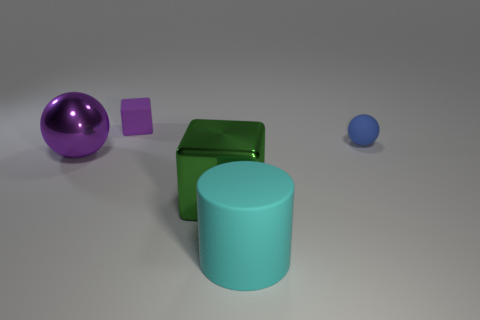Add 5 big yellow metal objects. How many objects exist? 10 Subtract all cylinders. How many objects are left? 4 Add 5 green shiny blocks. How many green shiny blocks are left? 6 Add 1 big cyan cylinders. How many big cyan cylinders exist? 2 Subtract 0 blue blocks. How many objects are left? 5 Subtract all large balls. Subtract all small cubes. How many objects are left? 3 